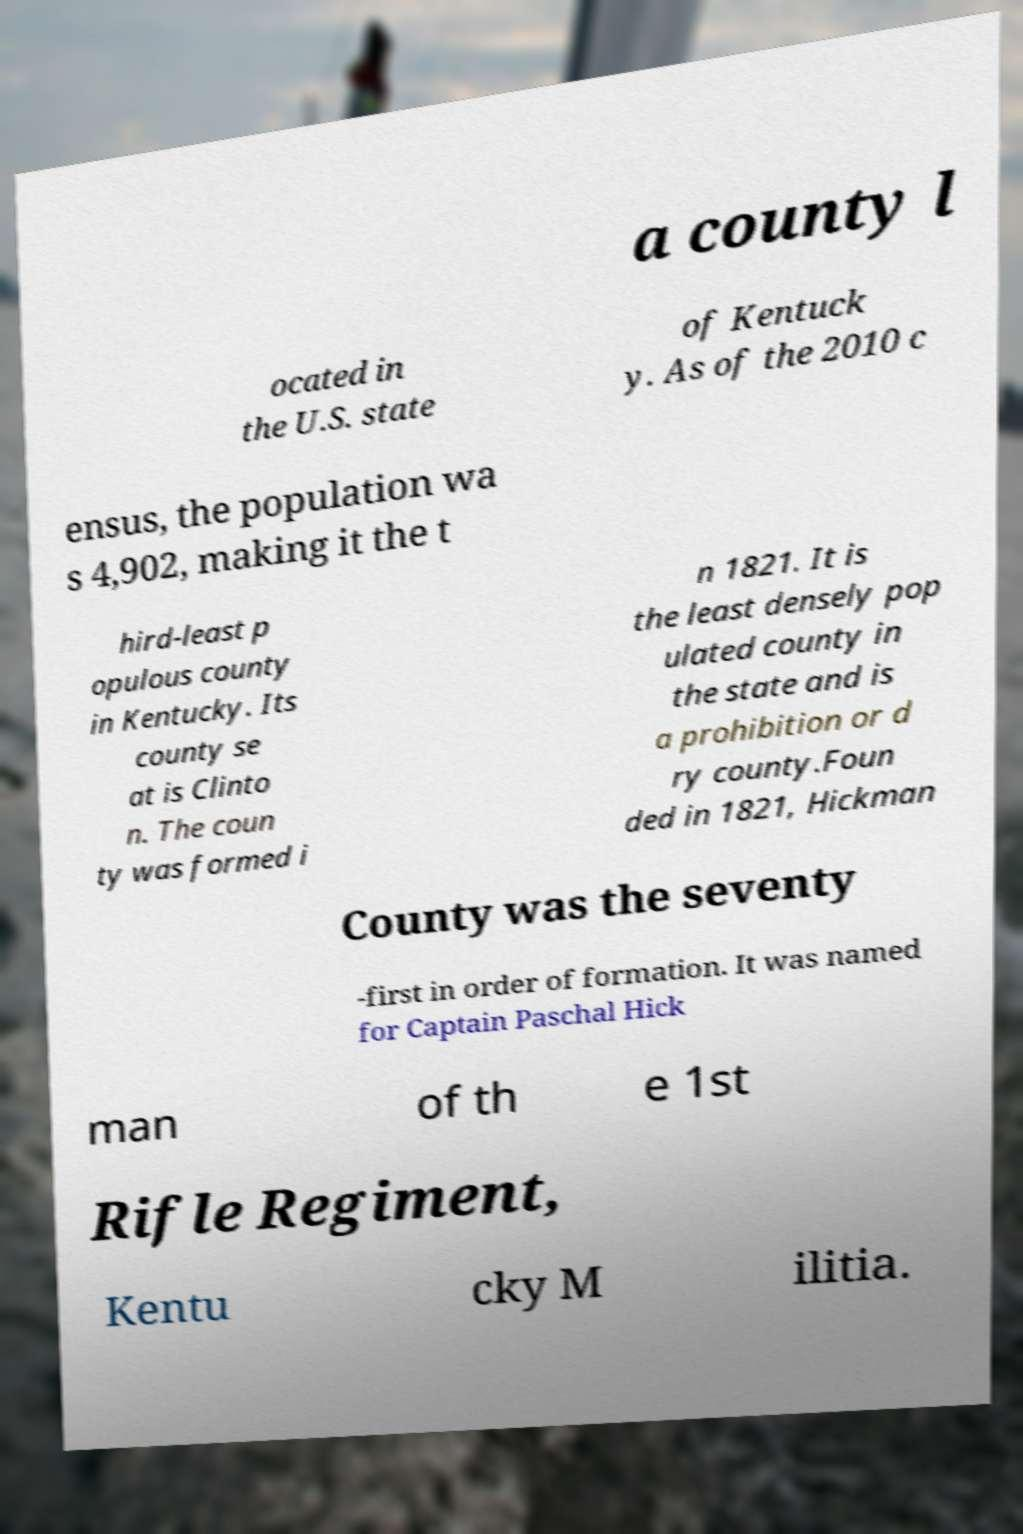What messages or text are displayed in this image? I need them in a readable, typed format. a county l ocated in the U.S. state of Kentuck y. As of the 2010 c ensus, the population wa s 4,902, making it the t hird-least p opulous county in Kentucky. Its county se at is Clinto n. The coun ty was formed i n 1821. It is the least densely pop ulated county in the state and is a prohibition or d ry county.Foun ded in 1821, Hickman County was the seventy -first in order of formation. It was named for Captain Paschal Hick man of th e 1st Rifle Regiment, Kentu cky M ilitia. 